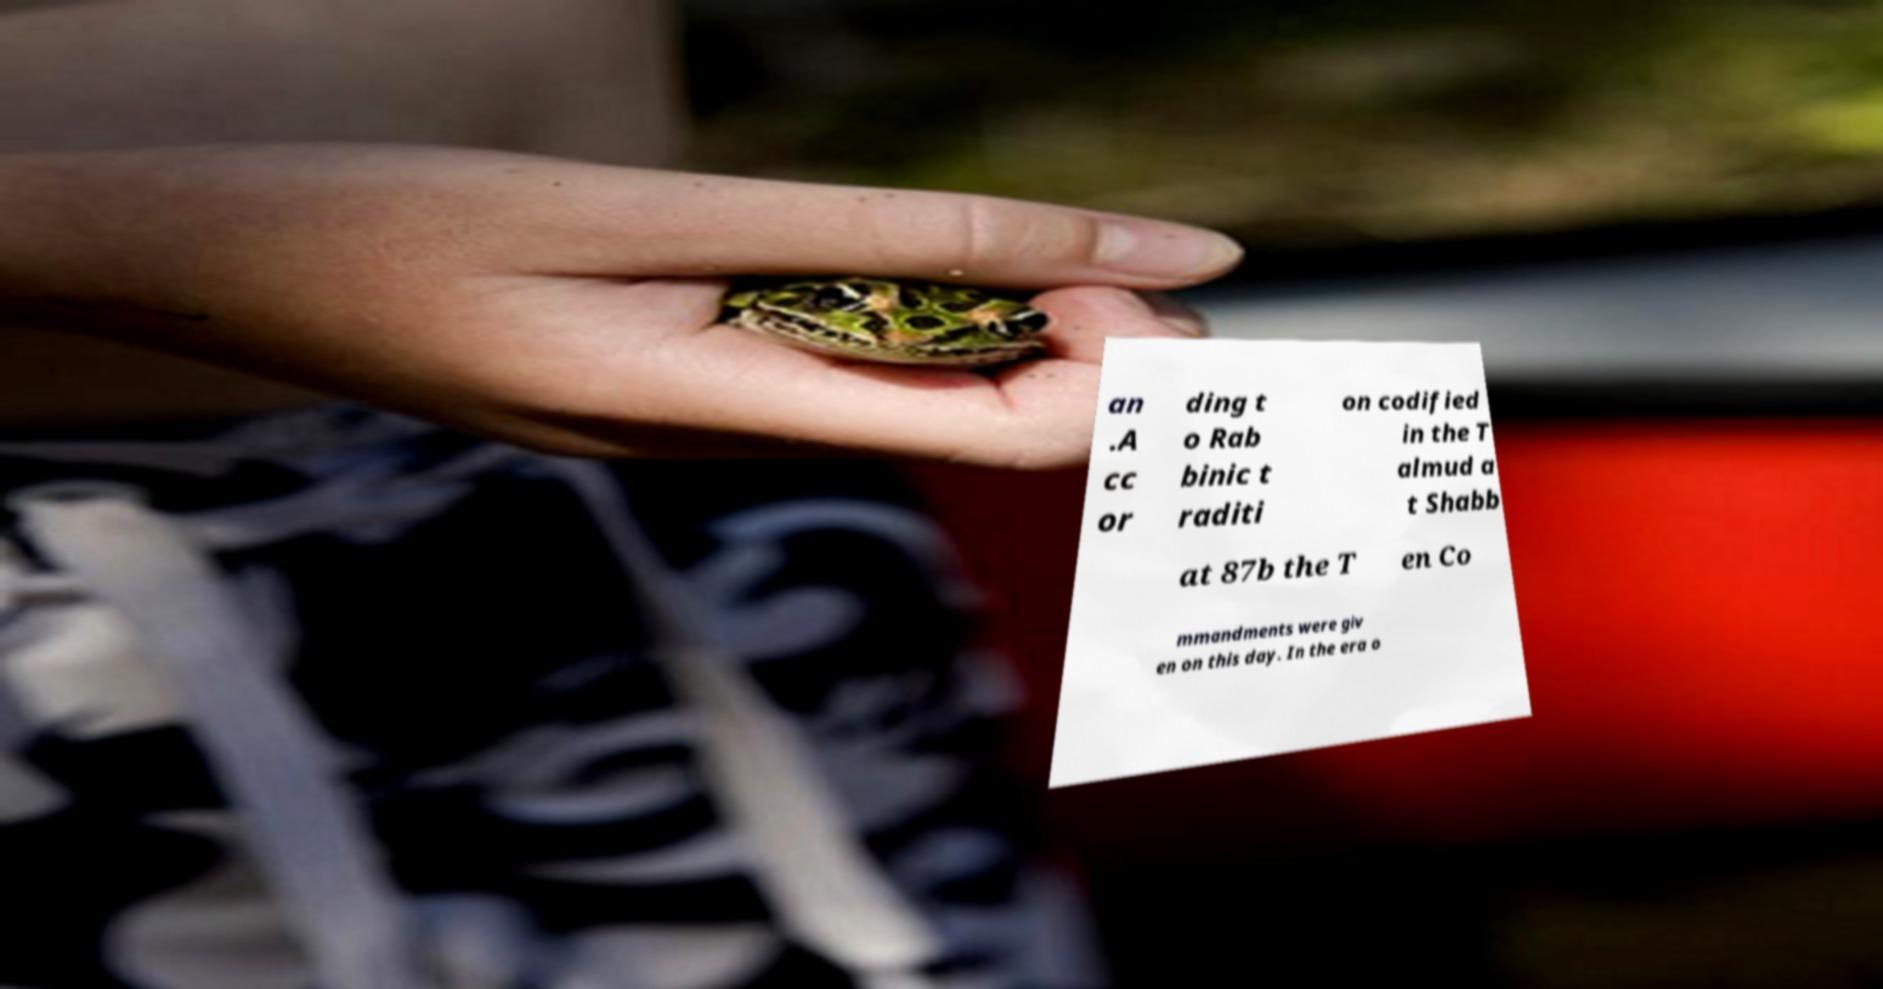I need the written content from this picture converted into text. Can you do that? an .A cc or ding t o Rab binic t raditi on codified in the T almud a t Shabb at 87b the T en Co mmandments were giv en on this day. In the era o 